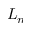<formula> <loc_0><loc_0><loc_500><loc_500>L _ { n }</formula> 